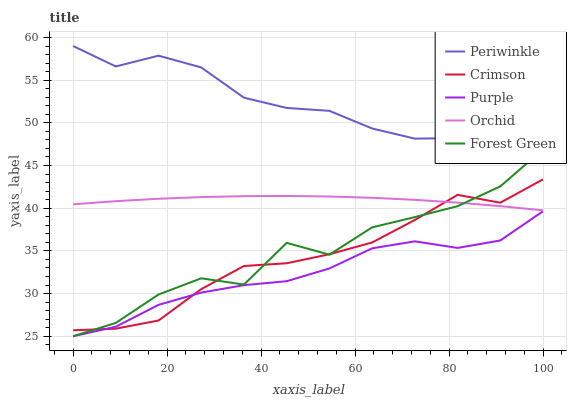Does Forest Green have the minimum area under the curve?
Answer yes or no. No. Does Forest Green have the maximum area under the curve?
Answer yes or no. No. Is Purple the smoothest?
Answer yes or no. No. Is Purple the roughest?
Answer yes or no. No. Does Periwinkle have the lowest value?
Answer yes or no. No. Does Forest Green have the highest value?
Answer yes or no. No. Is Purple less than Periwinkle?
Answer yes or no. Yes. Is Periwinkle greater than Crimson?
Answer yes or no. Yes. Does Purple intersect Periwinkle?
Answer yes or no. No. 